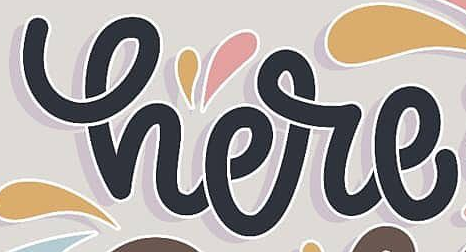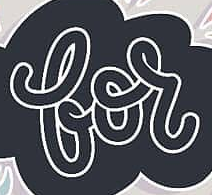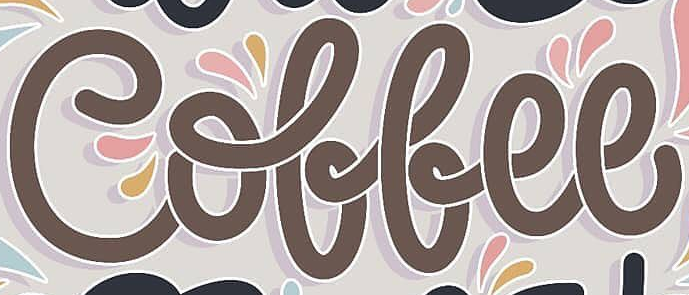What text appears in these images from left to right, separated by a semicolon? here; for; Coffee 